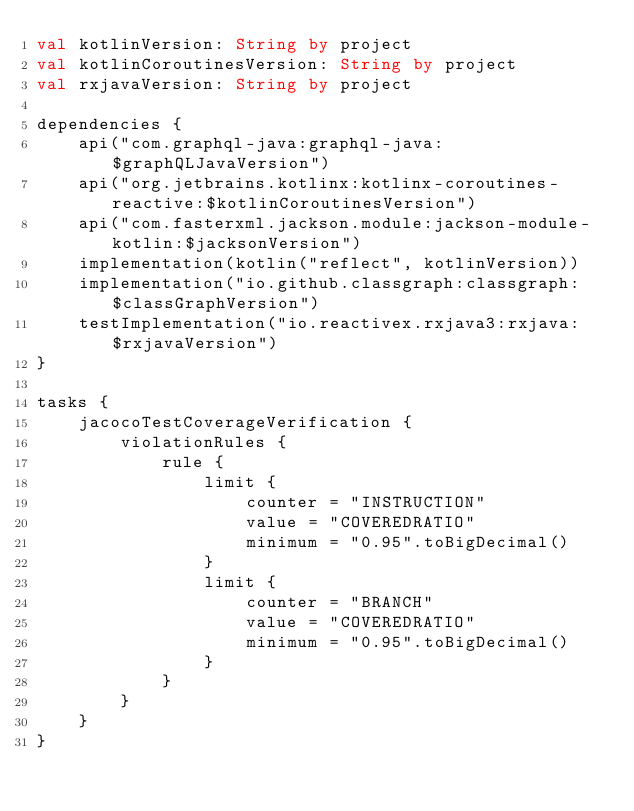Convert code to text. <code><loc_0><loc_0><loc_500><loc_500><_Kotlin_>val kotlinVersion: String by project
val kotlinCoroutinesVersion: String by project
val rxjavaVersion: String by project

dependencies {
    api("com.graphql-java:graphql-java:$graphQLJavaVersion")
    api("org.jetbrains.kotlinx:kotlinx-coroutines-reactive:$kotlinCoroutinesVersion")
    api("com.fasterxml.jackson.module:jackson-module-kotlin:$jacksonVersion")
    implementation(kotlin("reflect", kotlinVersion))
    implementation("io.github.classgraph:classgraph:$classGraphVersion")
    testImplementation("io.reactivex.rxjava3:rxjava:$rxjavaVersion")
}

tasks {
    jacocoTestCoverageVerification {
        violationRules {
            rule {
                limit {
                    counter = "INSTRUCTION"
                    value = "COVEREDRATIO"
                    minimum = "0.95".toBigDecimal()
                }
                limit {
                    counter = "BRANCH"
                    value = "COVEREDRATIO"
                    minimum = "0.95".toBigDecimal()
                }
            }
        }
    }
}
</code> 